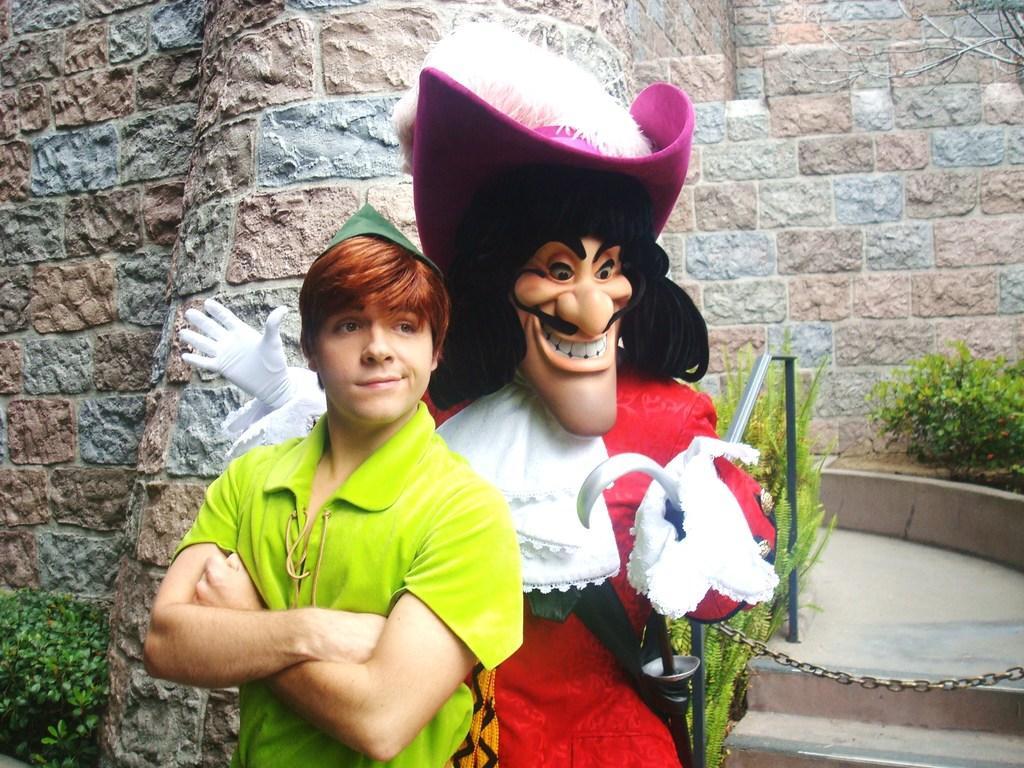Can you describe this image briefly? In this image I can see a man is standing beside a cartoon statue. The man is wearing a green color t-shirt. In the background I can see a wall and plants. 